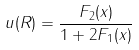Convert formula to latex. <formula><loc_0><loc_0><loc_500><loc_500>u ( R ) = \frac { F _ { 2 } ( x ) } { 1 + 2 F _ { 1 } ( x ) }</formula> 